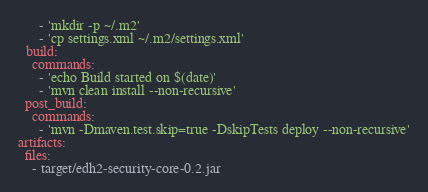Convert code to text. <code><loc_0><loc_0><loc_500><loc_500><_YAML_>      - 'mkdir -p ~/.m2'
      - 'cp settings.xml ~/.m2/settings.xml'
  build:
    commands:
      - 'echo Build started on $(date)'
      - 'mvn clean install --non-recursive'    
  post_build:
    commands:
      - 'mvn -Dmaven.test.skip=true -DskipTests deploy --non-recursive'
artifacts:
  files:
    - target/edh2-security-core-0.2.jar
</code> 